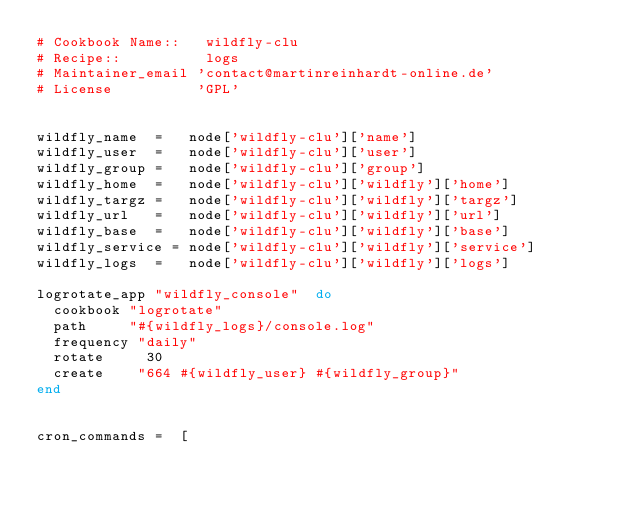<code> <loc_0><loc_0><loc_500><loc_500><_Ruby_># Cookbook Name::   wildfly-clu
# Recipe::          logs
# Maintainer_email 'contact@martinreinhardt-online.de'
# License          'GPL'


wildfly_name  =   node['wildfly-clu']['name']
wildfly_user  =   node['wildfly-clu']['user']
wildfly_group =   node['wildfly-clu']['group']
wildfly_home  =   node['wildfly-clu']['wildfly']['home']
wildfly_targz =   node['wildfly-clu']['wildfly']['targz']
wildfly_url   =   node['wildfly-clu']['wildfly']['url']
wildfly_base  =   node['wildfly-clu']['wildfly']['base']
wildfly_service = node['wildfly-clu']['wildfly']['service']
wildfly_logs  =   node['wildfly-clu']['wildfly']['logs']

logrotate_app "wildfly_console"  do
  cookbook "logrotate"
  path     "#{wildfly_logs}/console.log"
  frequency "daily"
  rotate     30
  create    "664 #{wildfly_user} #{wildfly_group}"
end


cron_commands =  [
</code> 